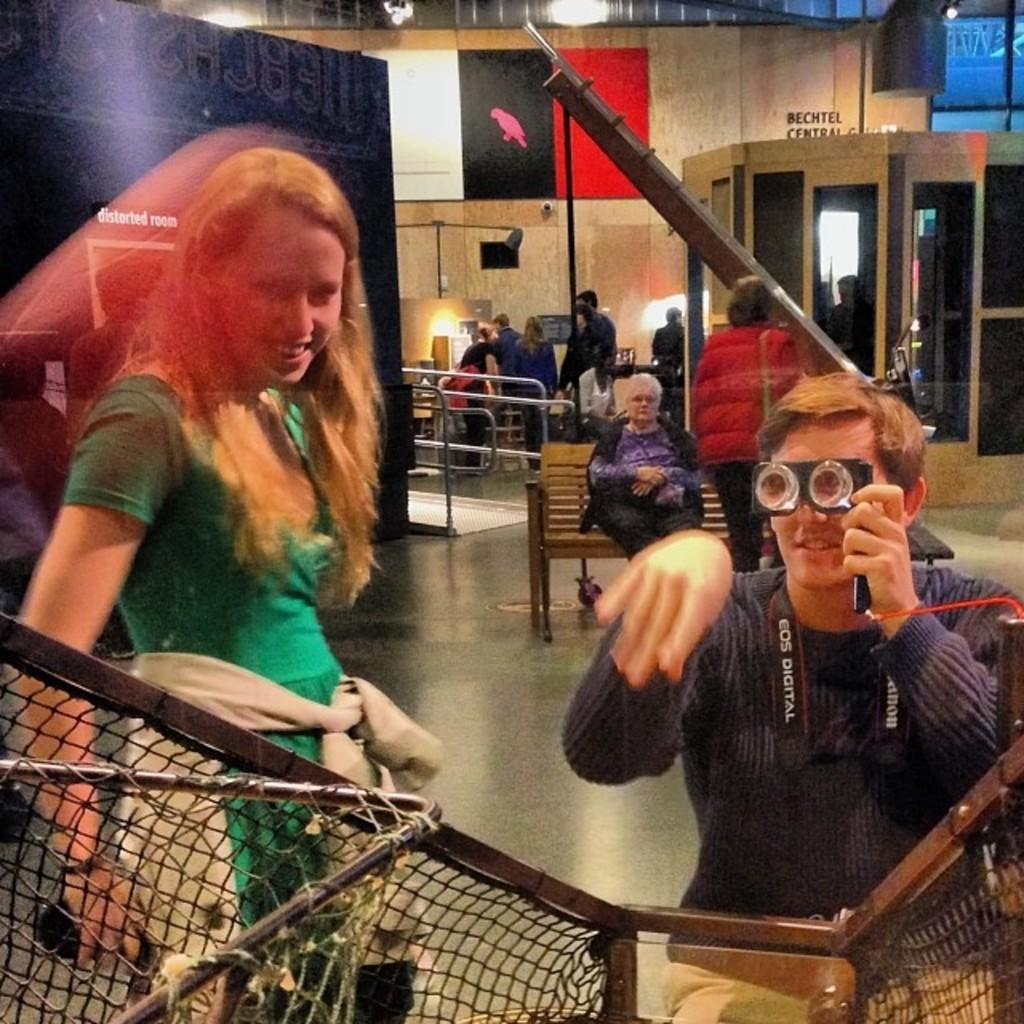How many people are in the image? There are people in the image, but the exact number is not specified. What type of surface is visible in the image? There is a floor in the image. What is the mesh used for in the image? The purpose of the mesh is not specified in the facts. What is the wall made of in the image? The material of the wall is not specified in the facts. What is the purpose of the lights in the image? The purpose of the lights is not specified in the facts. What are the boards used for in the image? The purpose of the boards is not specified in the facts. What is the railing used for in the image? The purpose of the railing is not specified in the facts. What are the glasses used for in the image? The purpose of the glasses is not specified in the facts. Can you describe the person sitting on a bench in the image? There is a person sitting on a bench in the image, but their appearance or any other details are not specified. What type of dog is sitting next to the person on the bench in the image? There is no dog present in the image. What type of lunch is being served on the table in the image? There is no mention of a table or lunch in the image. What question is being asked by the person sitting on the bench in the image? There is no indication of a question being asked in the image. 